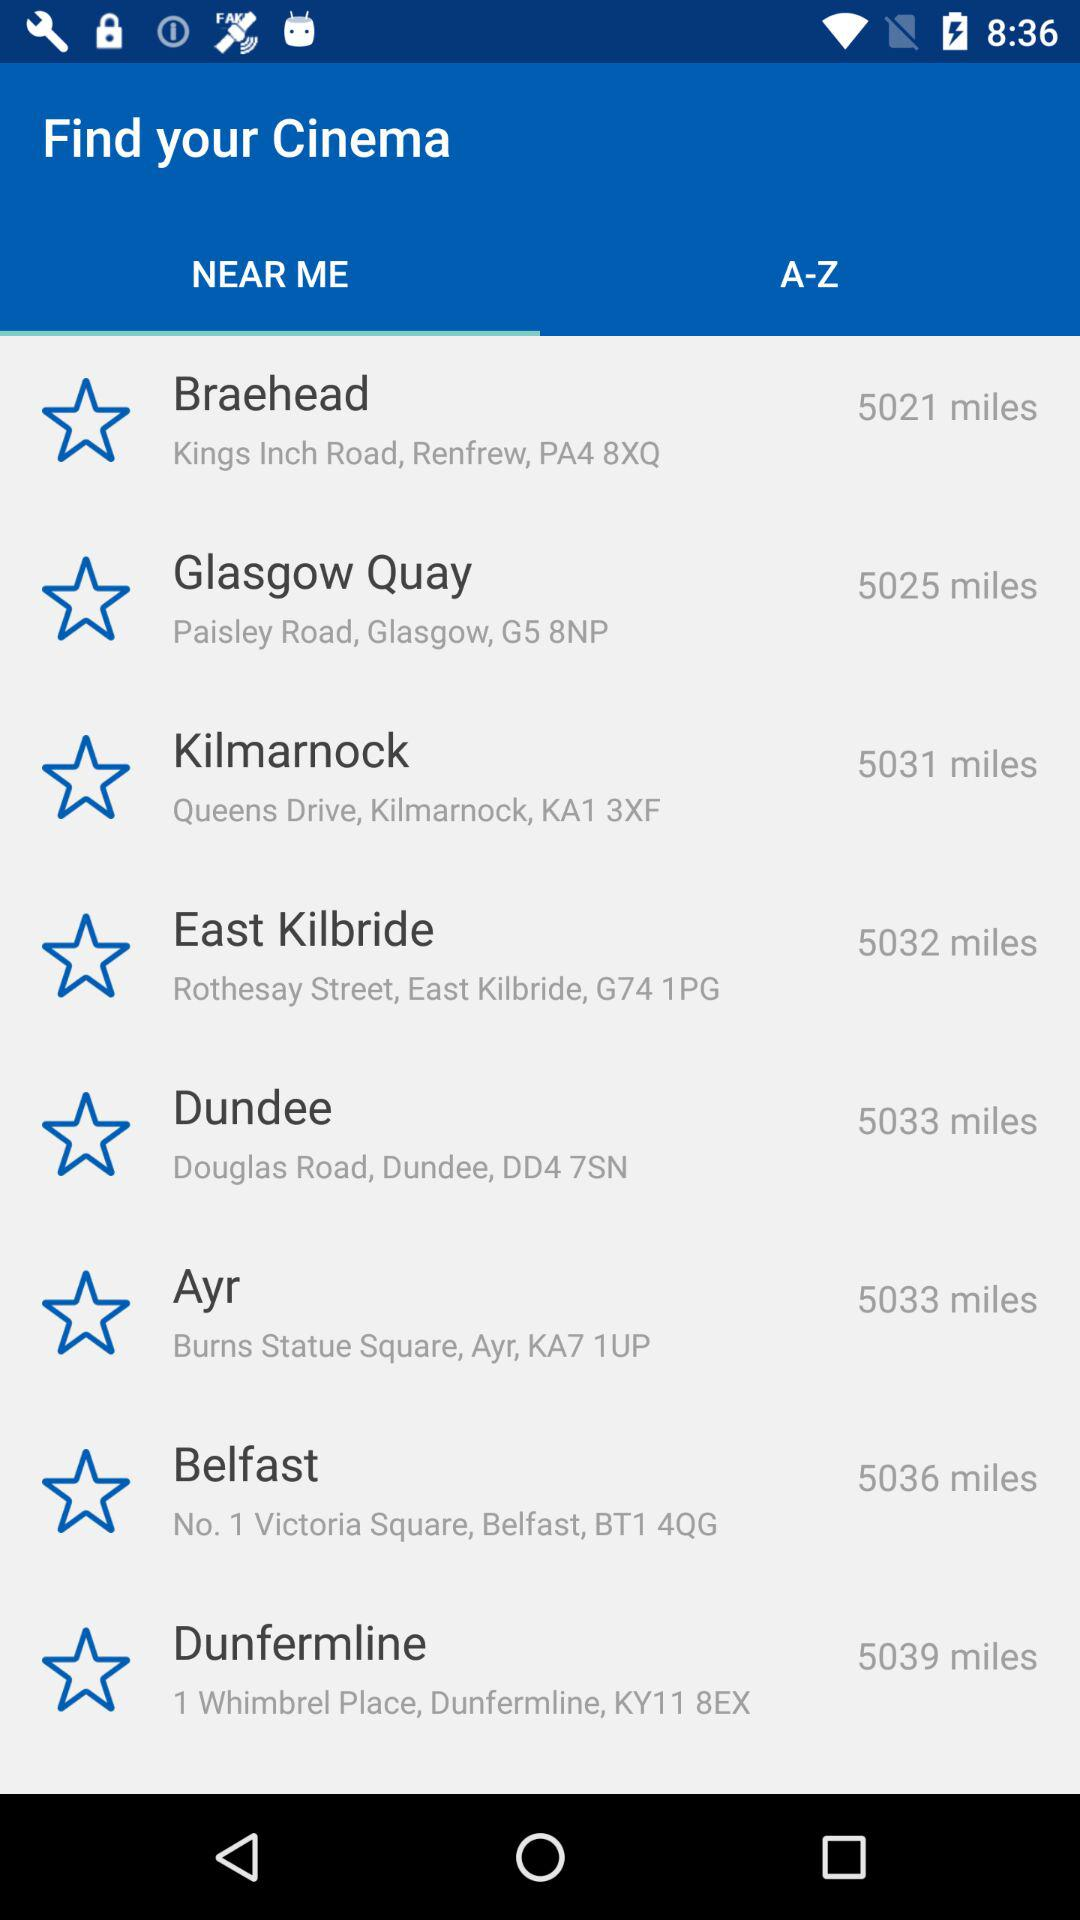What is the distance between Braehead and my location? The distance between Braehead and your location is 5021 miles. 